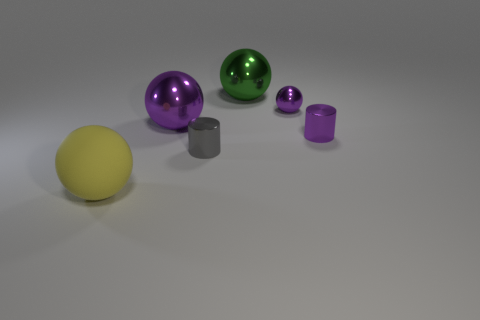There is a large metallic ball in front of the big green metallic sphere; is there a yellow object that is in front of it?
Provide a short and direct response. Yes. Is the shape of the big yellow object the same as the large purple shiny object?
Ensure brevity in your answer.  Yes. There is a large purple object that is the same material as the tiny gray cylinder; what shape is it?
Give a very brief answer. Sphere. There is a purple ball that is on the left side of the small purple metallic ball; does it have the same size as the metallic cylinder to the right of the large green thing?
Your answer should be compact. No. Are there more metal things to the left of the purple cylinder than large purple shiny balls right of the green metal sphere?
Make the answer very short. Yes. What number of other objects are the same color as the matte sphere?
Offer a very short reply. 0. Is the color of the tiny shiny ball the same as the small cylinder behind the tiny gray cylinder?
Give a very brief answer. Yes. How many cylinders are right of the small cylinder that is on the left side of the large green sphere?
Offer a terse response. 1. Are there any other things that have the same material as the large yellow object?
Your answer should be very brief. No. There is a small cylinder to the right of the big metallic thing behind the purple thing on the left side of the tiny gray metal thing; what is it made of?
Make the answer very short. Metal. 